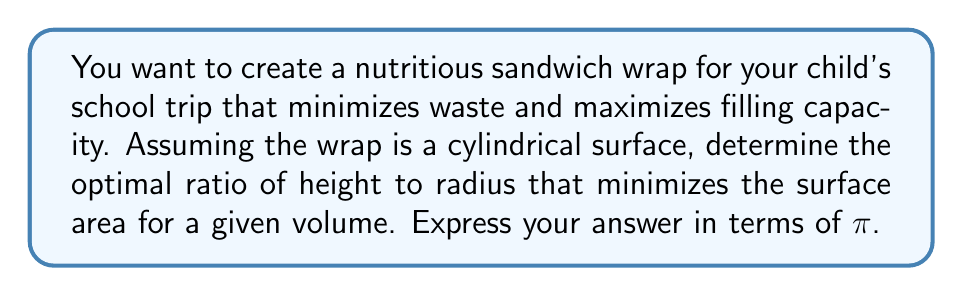Teach me how to tackle this problem. Let's approach this step-by-step:

1) Let $r$ be the radius of the base and $h$ be the height of the cylinder.

2) The volume of the cylinder is given by:
   $$V = πr^2h$$

3) The surface area of the cylinder (including the circular ends) is:
   $$S = 2πr^2 + 2πrh$$

4) We want to minimize $S$ for a given $V$. This is a problem of constrained optimization.

5) Using the method of Lagrange multipliers, we form the function:
   $$F(r,h,λ) = 2πr^2 + 2πrh + λ(V - πr^2h)$$

6) Taking partial derivatives and setting them to zero:
   $$\frac{∂F}{∂r} = 4πr + 2πh - 2λπrh = 0$$
   $$\frac{∂F}{∂h} = 2πr - λπr^2 = 0$$
   $$\frac{∂F}{∂λ} = V - πr^2h = 0$$

7) From the second equation:
   $$λ = \frac{2}{r}$$

8) Substituting this into the first equation:
   $$4πr + 2πh - 2(\frac{2}{r})πrh = 0$$
   $$4r + 2h - 4h = 0$$
   $$4r - 2h = 0$$
   $$2r = h$$

9) This means the optimal ratio of height to radius is:
   $$\frac{h}{r} = 2$$

Therefore, the optimal shape for the sandwich wrap is a cylinder where the height is twice the radius.
Answer: $\frac{h}{r} = 2$ 